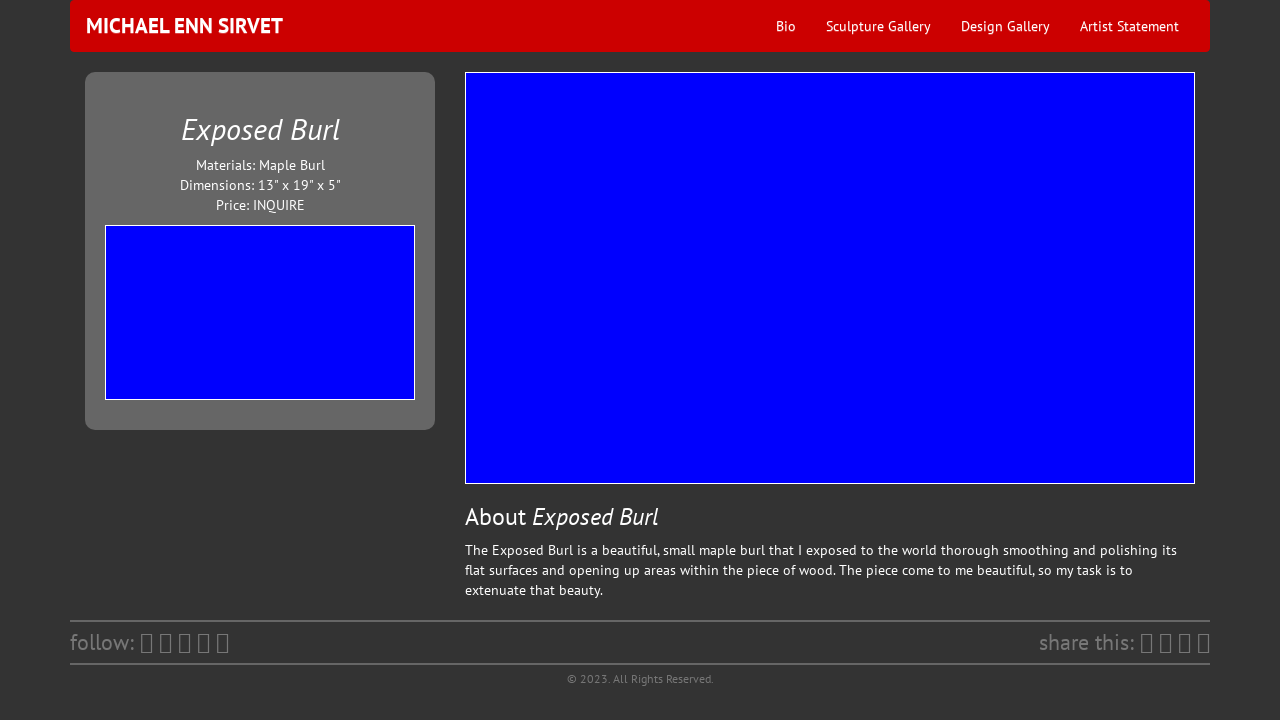Can you tell me more about the artwork 'Exposed Burl' showcased on the website? 'Exposed Burl' is a stunning piece created by Michael Enn Sirvet. It features a Maple Burl material, and Sirvet has skillfully polished its flat surfaces while opening up internal areas to highlight the natural beauty of the wood. Measuring 13" x 19" x 5", the piece emphasizes organic form and texture, inviting viewers to appreciate the intricate details and the artist's craftsmanship. 